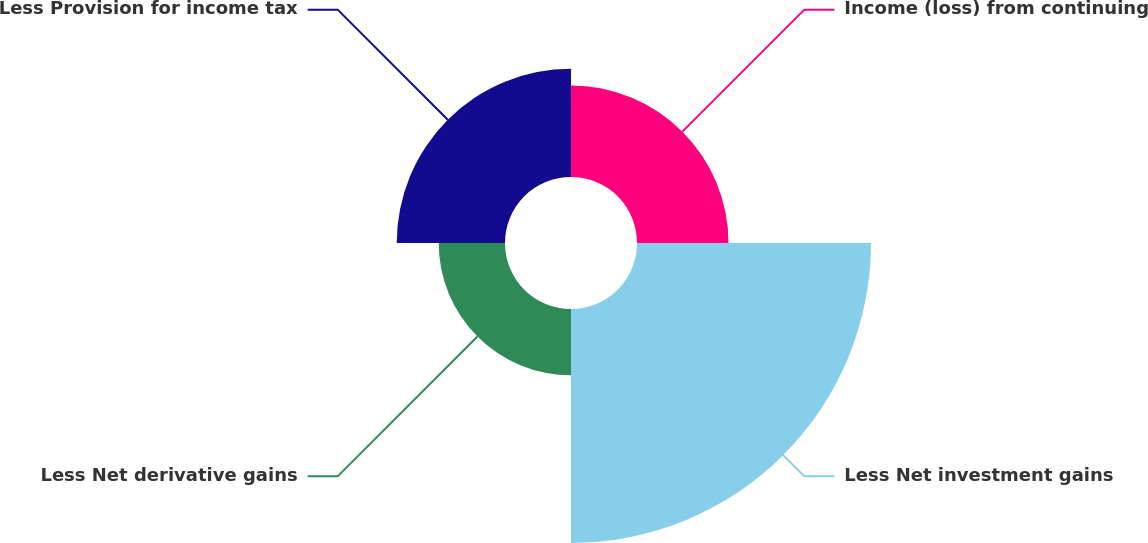Convert chart to OTSL. <chart><loc_0><loc_0><loc_500><loc_500><pie_chart><fcel>Income (loss) from continuing<fcel>Less Net investment gains<fcel>Less Net derivative gains<fcel>Less Provision for income tax<nl><fcel>18.3%<fcel>46.8%<fcel>13.26%<fcel>21.65%<nl></chart> 